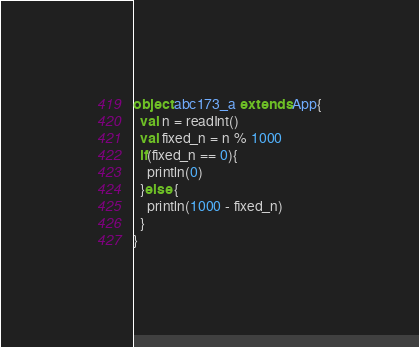Convert code to text. <code><loc_0><loc_0><loc_500><loc_500><_Scala_>
object abc173_a extends App{
  val n = readInt()
  val fixed_n = n % 1000
  if(fixed_n == 0){
    println(0)
  }else {
    println(1000 - fixed_n)
  }
}
</code> 